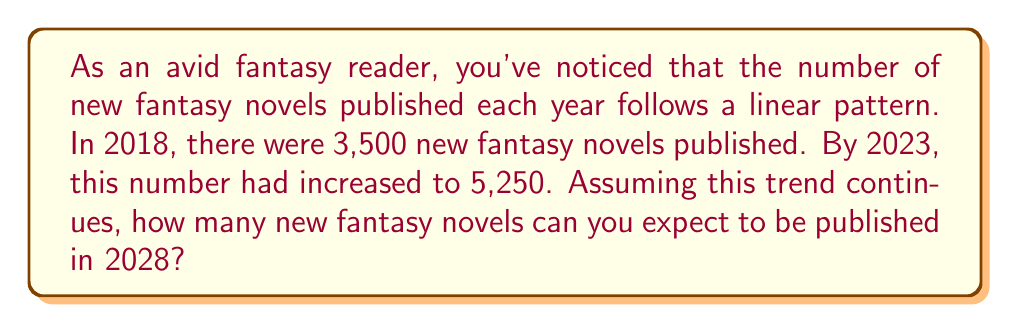Provide a solution to this math problem. Let's approach this step-by-step:

1) First, we need to find the rate at which new fantasy novels are being published each year.

2) We have two data points:
   - 2018: 3,500 novels
   - 2023: 5,250 novels

3) The time difference between these points is 5 years (2023 - 2018 = 5).

4) The increase in novels over this period is:
   $5,250 - 3,500 = 1,750$ novels

5) To find the yearly rate, we divide this increase by the number of years:
   $\text{Rate} = \frac{1,750}{5} = 350$ novels per year

6) Now that we have the rate, we can use the linear equation:
   $y = mx + b$
   Where $m$ is the rate, $x$ is the number of years from our starting point, and $b$ is the initial value.

7) We want to find the number of novels in 2028, which is 10 years from our initial point in 2018.

8) Plugging in our values:
   $y = 350x + 3,500$
   $y = 350(10) + 3,500$
   $y = 3,500 + 3,500$
   $y = 7,000$

Therefore, in 2028, we can expect 7,000 new fantasy novels to be published.
Answer: 7,000 novels 